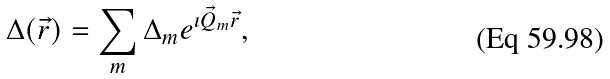<formula> <loc_0><loc_0><loc_500><loc_500>\Delta ( \vec { r } ) = \sum _ { m } \Delta _ { m } e ^ { \imath \vec { Q } _ { m } \vec { r } } ,</formula> 